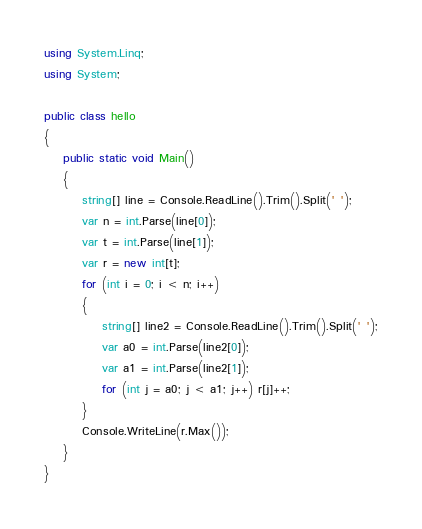Convert code to text. <code><loc_0><loc_0><loc_500><loc_500><_C#_>using System.Linq;
using System;

public class hello
{
    public static void Main()
    {
        string[] line = Console.ReadLine().Trim().Split(' ');
        var n = int.Parse(line[0]);
        var t = int.Parse(line[1]);
        var r = new int[t];
        for (int i = 0; i < n; i++)
        {
            string[] line2 = Console.ReadLine().Trim().Split(' ');
            var a0 = int.Parse(line2[0]);
            var a1 = int.Parse(line2[1]);
            for (int j = a0; j < a1; j++) r[j]++;
        }
        Console.WriteLine(r.Max());
    }
}</code> 